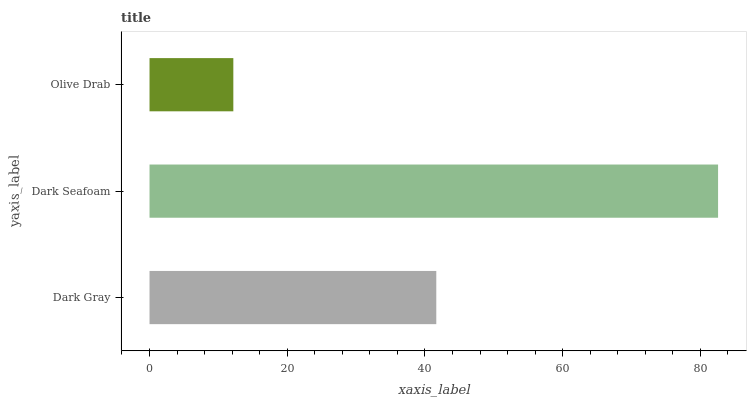Is Olive Drab the minimum?
Answer yes or no. Yes. Is Dark Seafoam the maximum?
Answer yes or no. Yes. Is Dark Seafoam the minimum?
Answer yes or no. No. Is Olive Drab the maximum?
Answer yes or no. No. Is Dark Seafoam greater than Olive Drab?
Answer yes or no. Yes. Is Olive Drab less than Dark Seafoam?
Answer yes or no. Yes. Is Olive Drab greater than Dark Seafoam?
Answer yes or no. No. Is Dark Seafoam less than Olive Drab?
Answer yes or no. No. Is Dark Gray the high median?
Answer yes or no. Yes. Is Dark Gray the low median?
Answer yes or no. Yes. Is Dark Seafoam the high median?
Answer yes or no. No. Is Olive Drab the low median?
Answer yes or no. No. 